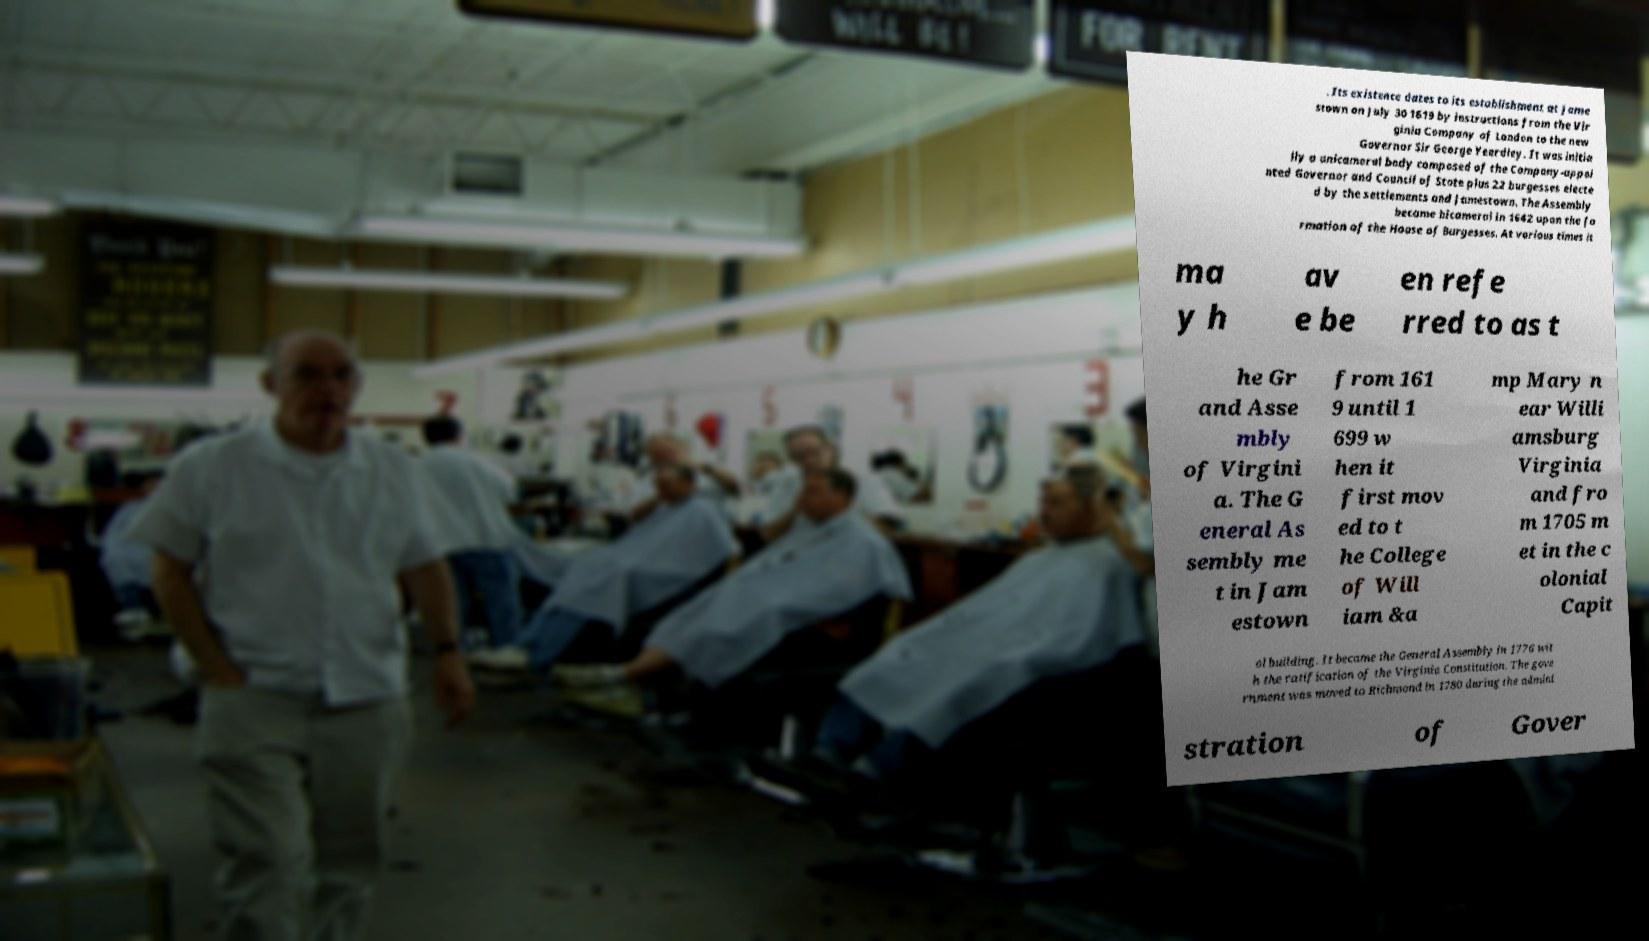Could you assist in decoding the text presented in this image and type it out clearly? . Its existence dates to its establishment at Jame stown on July 30 1619 by instructions from the Vir ginia Company of London to the new Governor Sir George Yeardley. It was initia lly a unicameral body composed of the Company-appoi nted Governor and Council of State plus 22 burgesses electe d by the settlements and Jamestown. The Assembly became bicameral in 1642 upon the fo rmation of the House of Burgesses. At various times it ma y h av e be en refe rred to as t he Gr and Asse mbly of Virgini a. The G eneral As sembly me t in Jam estown from 161 9 until 1 699 w hen it first mov ed to t he College of Will iam &a mp Mary n ear Willi amsburg Virginia and fro m 1705 m et in the c olonial Capit ol building. It became the General Assembly in 1776 wit h the ratification of the Virginia Constitution. The gove rnment was moved to Richmond in 1780 during the admini stration of Gover 